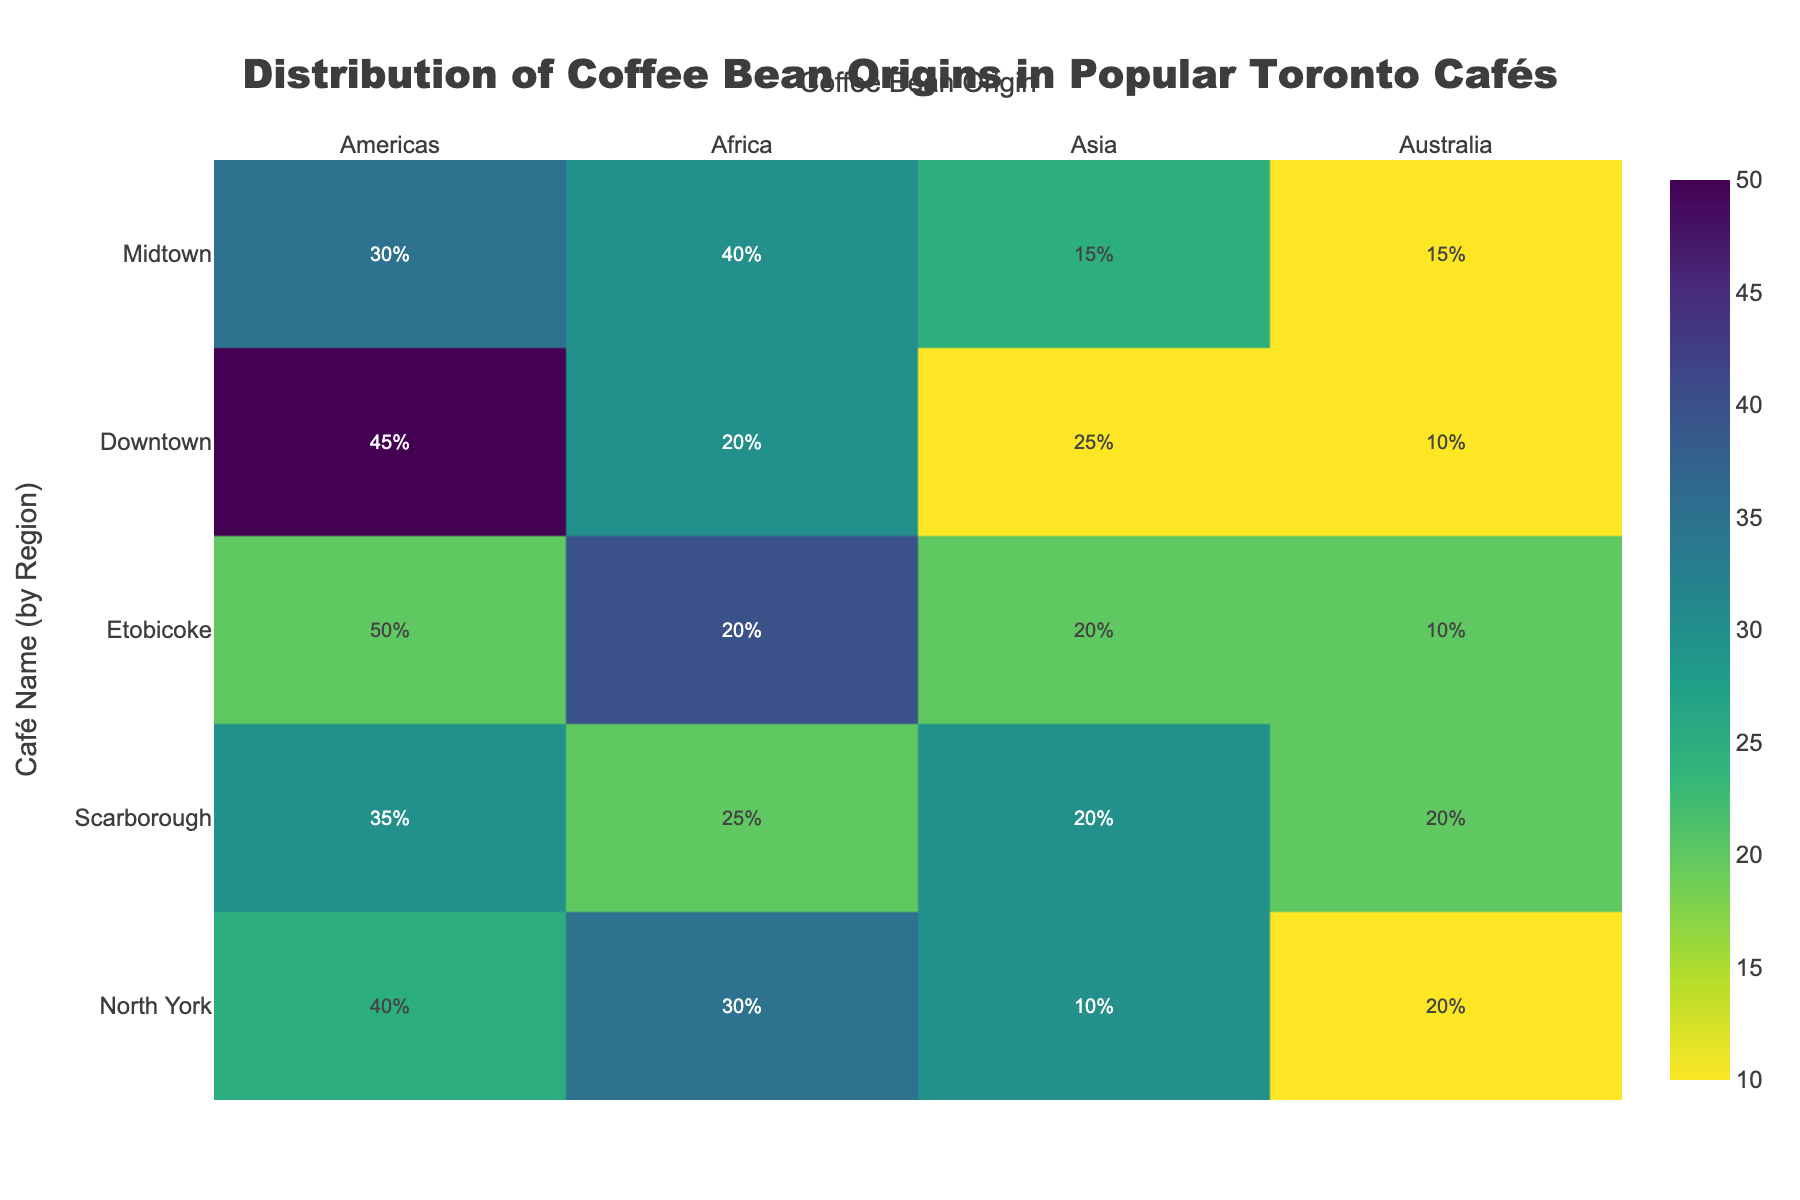What's the title of the figure? The title of the figure can be found at the top of the plot, usually centered and in a larger font size compared to other texts. It provides a summary of what the figure represents.
Answer: Distribution of Coffee Bean Origins in Popular Toronto Cafés Which café in Downtown has the highest percentage of coffee beans from the Americas? Look at the row for Downtown cafés and identify the café with the highest value under the Americas column.
Answer: Café Exotica How many cafés are from the Midtown region? Count the number of rows labeled as Midtown in the Region column.
Answer: 2 Which region has the highest average percentage of coffee beans from Africa? Calculate the average value for the Africa column for each region, then compare these averages to determine the highest.
Answer: North York Compare the percentage of coffee beans from Australia between Brew Haven and Toronto Brews. Which café has a higher percentage? Look at the values under the Australia column for both Brew Haven and Toronto Brews, then compare these two values.
Answer: Tie What is the combined percentage of coffee beans from Asia for Exotic Beans and Coffee Cloud? Add the values under the Asia column for Exotic Beans and Coffee Cloud.
Answer: 50% Are there any regions where the percentages of coffee beans from the Americas are consistently higher than 30%? Check if all values in the Americas column for a specific region are greater than 30%.
Answer: No What's the percentage difference in coffee beans from Africa between Bean Bliss and Roast Masters? Subtract the percentage of African coffee beans for Roast Masters from that for Bean Bliss.
Answer: 20% Which café has the lowest percentage of coffee beans from Asia, and in which region is it located? Identify the café with the minimum value in the Asia column and note its corresponding region.
Answer: Café Patagonia, North York Is there a café with an equal percentage of coffee beans from both the Americas and Australia? If yes, name the café and its region. Look for rows where the values under Americas and Australia columns are the same.
Answer: Coffee Cloud, Scarborough 